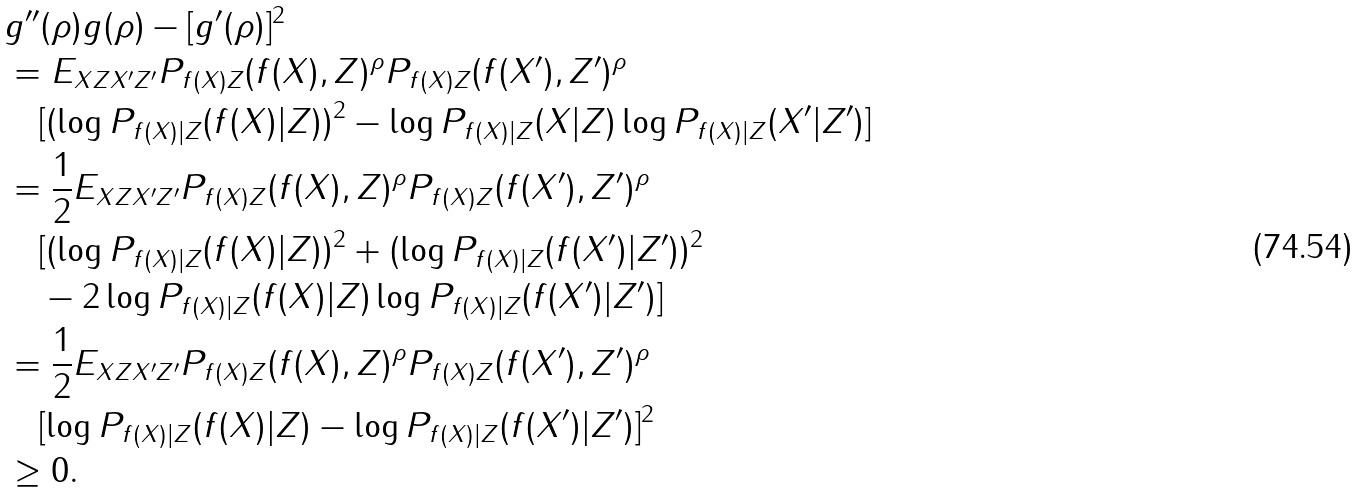Convert formula to latex. <formula><loc_0><loc_0><loc_500><loc_500>& g ^ { \prime \prime } ( \rho ) g ( \rho ) - [ g ^ { \prime } ( \rho ) ] ^ { 2 } \\ & = E _ { X Z X ^ { \prime } Z ^ { \prime } } P _ { f ( X ) Z } ( f ( X ) , Z ) ^ { \rho } P _ { f ( X ) Z } ( f ( X ^ { \prime } ) , Z ^ { \prime } ) ^ { \rho } \\ & \quad [ ( \log P _ { f ( X ) | Z } ( f ( X ) | Z ) ) ^ { 2 } - \log P _ { f ( X ) | Z } ( X | Z ) \log P _ { f ( X ) | Z } ( X ^ { \prime } | Z ^ { \prime } ) ] \\ & = \frac { 1 } { 2 } E _ { X Z X ^ { \prime } Z ^ { \prime } } P _ { f ( X ) Z } ( f ( X ) , Z ) ^ { \rho } P _ { f ( X ) Z } ( f ( X ^ { \prime } ) , Z ^ { \prime } ) ^ { \rho } \\ & \quad [ ( \log P _ { f ( X ) | Z } ( f ( X ) | Z ) ) ^ { 2 } + ( \log P _ { f ( X ) | Z } ( f ( X ^ { \prime } ) | Z ^ { \prime } ) ) ^ { 2 } \\ & \quad - 2 \log P _ { f ( X ) | Z } ( f ( X ) | Z ) \log P _ { f ( X ) | Z } ( f ( X ^ { \prime } ) | Z ^ { \prime } ) ] \\ & = \frac { 1 } { 2 } E _ { X Z X ^ { \prime } Z ^ { \prime } } P _ { f ( X ) Z } ( f ( X ) , Z ) ^ { \rho } P _ { f ( X ) Z } ( f ( X ^ { \prime } ) , Z ^ { \prime } ) ^ { \rho } \\ & \quad [ \log P _ { f ( X ) | Z } ( f ( X ) | Z ) - \log P _ { f ( X ) | Z } ( f ( X ^ { \prime } ) | Z ^ { \prime } ) ] ^ { 2 } \\ & \geq 0 .</formula> 